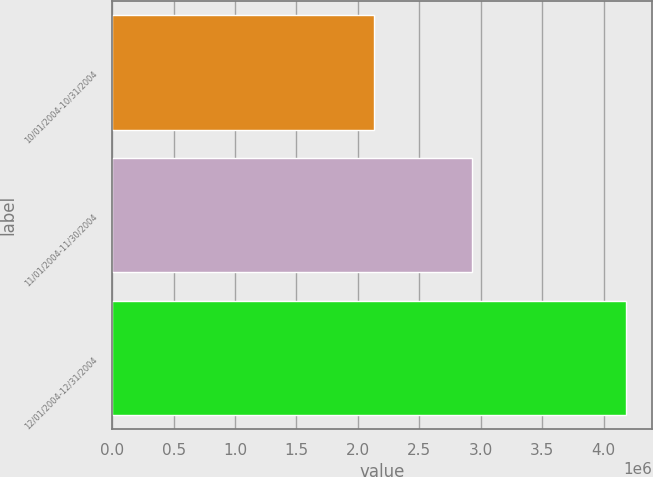Convert chart to OTSL. <chart><loc_0><loc_0><loc_500><loc_500><bar_chart><fcel>10/01/2004-10/31/2004<fcel>11/01/2004-11/30/2004<fcel>12/01/2004-12/31/2004<nl><fcel>2.135e+06<fcel>2.931e+06<fcel>4.1838e+06<nl></chart> 